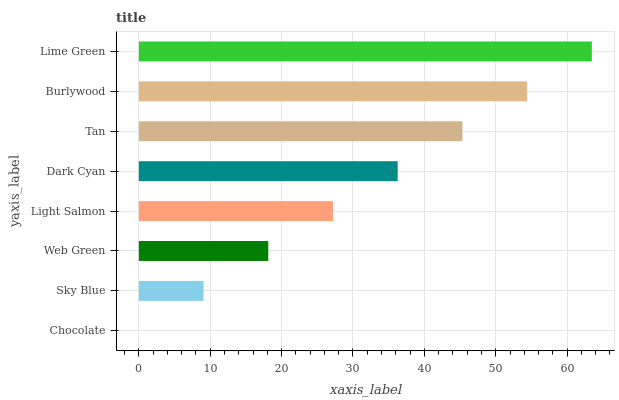Is Chocolate the minimum?
Answer yes or no. Yes. Is Lime Green the maximum?
Answer yes or no. Yes. Is Sky Blue the minimum?
Answer yes or no. No. Is Sky Blue the maximum?
Answer yes or no. No. Is Sky Blue greater than Chocolate?
Answer yes or no. Yes. Is Chocolate less than Sky Blue?
Answer yes or no. Yes. Is Chocolate greater than Sky Blue?
Answer yes or no. No. Is Sky Blue less than Chocolate?
Answer yes or no. No. Is Dark Cyan the high median?
Answer yes or no. Yes. Is Light Salmon the low median?
Answer yes or no. Yes. Is Lime Green the high median?
Answer yes or no. No. Is Dark Cyan the low median?
Answer yes or no. No. 